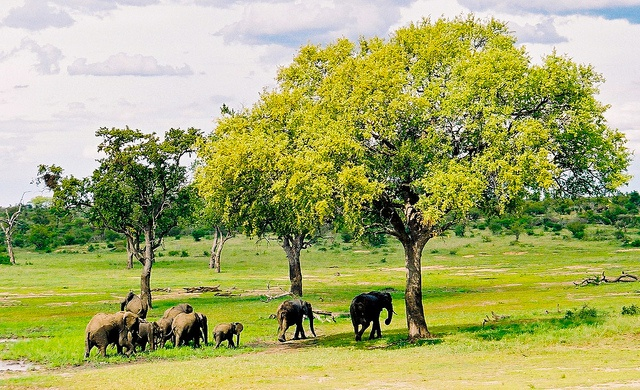Describe the objects in this image and their specific colors. I can see elephant in white, black, olive, and tan tones, elephant in white, black, gray, darkgreen, and olive tones, elephant in white, black, tan, gray, and olive tones, elephant in white, black, and tan tones, and elephant in white, black, olive, gray, and tan tones in this image. 